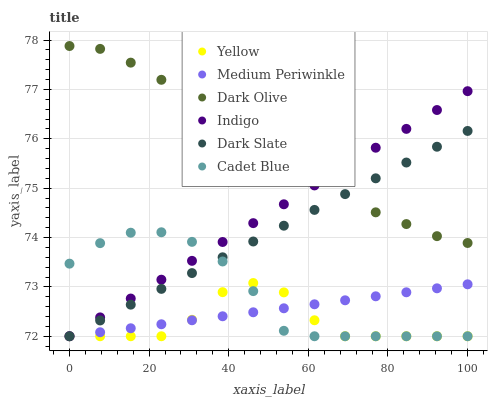Does Yellow have the minimum area under the curve?
Answer yes or no. Yes. Does Dark Olive have the maximum area under the curve?
Answer yes or no. Yes. Does Indigo have the minimum area under the curve?
Answer yes or no. No. Does Indigo have the maximum area under the curve?
Answer yes or no. No. Is Medium Periwinkle the smoothest?
Answer yes or no. Yes. Is Dark Olive the roughest?
Answer yes or no. Yes. Is Indigo the smoothest?
Answer yes or no. No. Is Indigo the roughest?
Answer yes or no. No. Does Cadet Blue have the lowest value?
Answer yes or no. Yes. Does Dark Olive have the lowest value?
Answer yes or no. No. Does Dark Olive have the highest value?
Answer yes or no. Yes. Does Indigo have the highest value?
Answer yes or no. No. Is Medium Periwinkle less than Dark Olive?
Answer yes or no. Yes. Is Dark Olive greater than Yellow?
Answer yes or no. Yes. Does Yellow intersect Cadet Blue?
Answer yes or no. Yes. Is Yellow less than Cadet Blue?
Answer yes or no. No. Is Yellow greater than Cadet Blue?
Answer yes or no. No. Does Medium Periwinkle intersect Dark Olive?
Answer yes or no. No. 